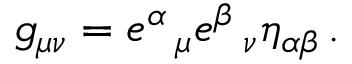Convert formula to latex. <formula><loc_0><loc_0><loc_500><loc_500>g _ { \mu \nu } = e ^ { \alpha } \, _ { \mu } e ^ { \beta } \, _ { \nu } \eta _ { \alpha \beta } \, .</formula> 